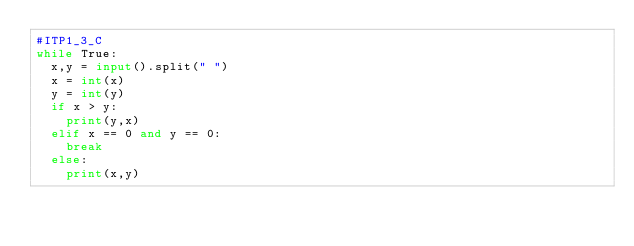Convert code to text. <code><loc_0><loc_0><loc_500><loc_500><_Python_>#ITP1_3_C
while True:
  x,y = input().split(" ")
  x = int(x)
  y = int(y)
  if x > y:
    print(y,x)
  elif x == 0 and y == 0:
    break
  else:
    print(x,y)
</code> 